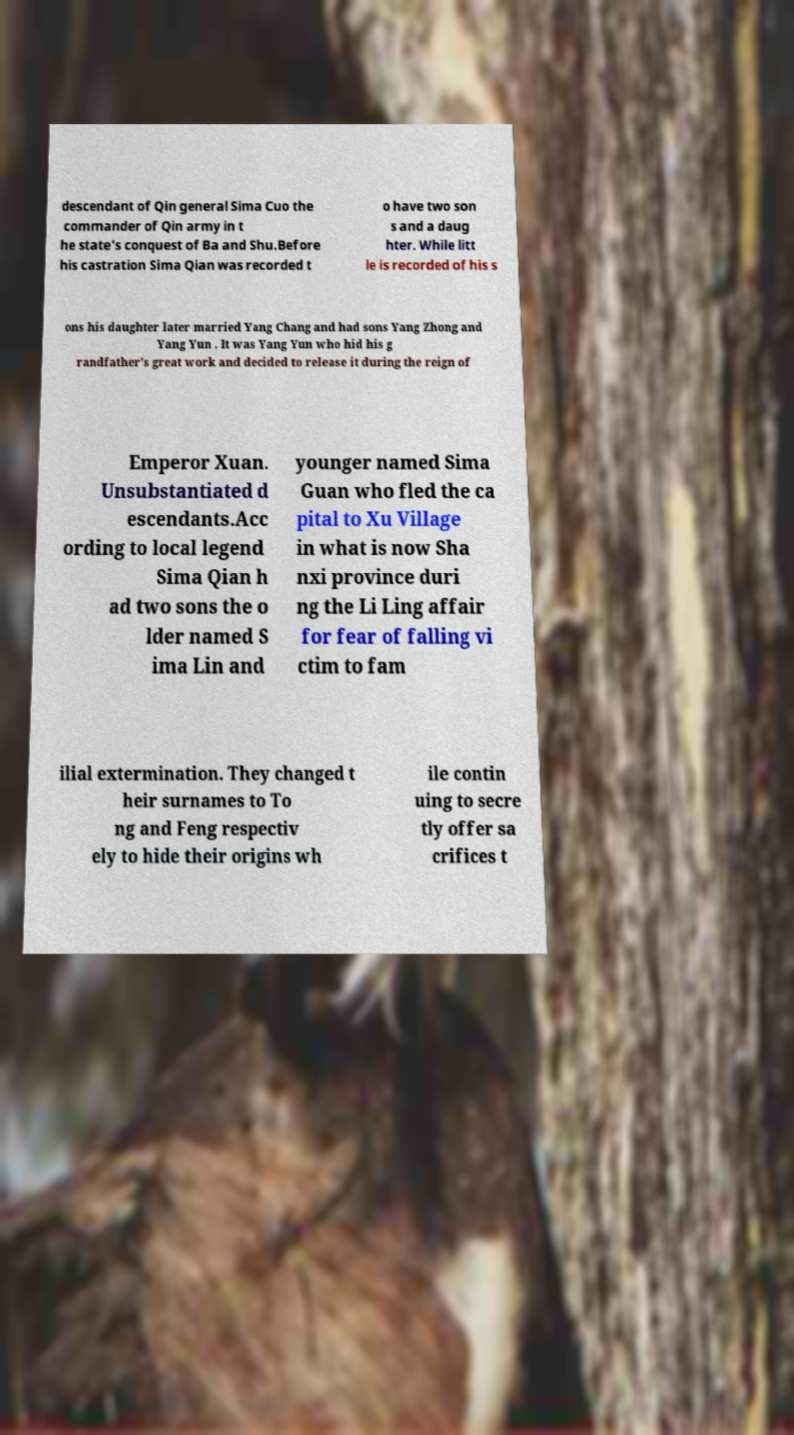Could you extract and type out the text from this image? descendant of Qin general Sima Cuo the commander of Qin army in t he state's conquest of Ba and Shu.Before his castration Sima Qian was recorded t o have two son s and a daug hter. While litt le is recorded of his s ons his daughter later married Yang Chang and had sons Yang Zhong and Yang Yun . It was Yang Yun who hid his g randfather's great work and decided to release it during the reign of Emperor Xuan. Unsubstantiated d escendants.Acc ording to local legend Sima Qian h ad two sons the o lder named S ima Lin and younger named Sima Guan who fled the ca pital to Xu Village in what is now Sha nxi province duri ng the Li Ling affair for fear of falling vi ctim to fam ilial extermination. They changed t heir surnames to To ng and Feng respectiv ely to hide their origins wh ile contin uing to secre tly offer sa crifices t 